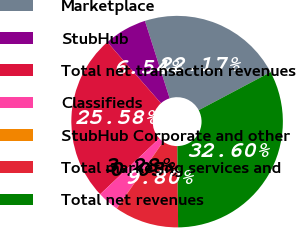Convert chart. <chart><loc_0><loc_0><loc_500><loc_500><pie_chart><fcel>Marketplace<fcel>StubHub<fcel>Total net transaction revenues<fcel>Classifieds<fcel>StubHub Corporate and other<fcel>Total marketing services and<fcel>Total net revenues<nl><fcel>22.17%<fcel>6.54%<fcel>25.58%<fcel>3.28%<fcel>0.03%<fcel>9.8%<fcel>32.6%<nl></chart> 